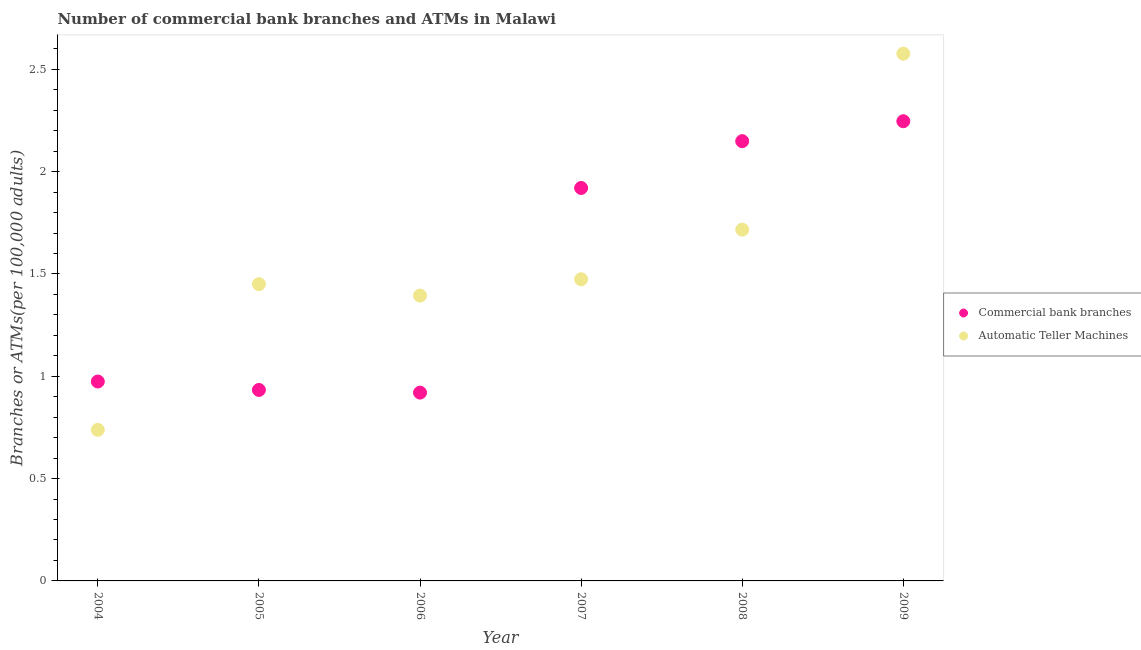Is the number of dotlines equal to the number of legend labels?
Your answer should be compact. Yes. What is the number of atms in 2009?
Provide a succinct answer. 2.58. Across all years, what is the maximum number of commercal bank branches?
Give a very brief answer. 2.25. Across all years, what is the minimum number of atms?
Your response must be concise. 0.74. What is the total number of commercal bank branches in the graph?
Ensure brevity in your answer.  9.14. What is the difference between the number of atms in 2004 and that in 2007?
Offer a very short reply. -0.74. What is the difference between the number of atms in 2007 and the number of commercal bank branches in 2008?
Your answer should be compact. -0.68. What is the average number of atms per year?
Your answer should be compact. 1.56. In the year 2009, what is the difference between the number of commercal bank branches and number of atms?
Ensure brevity in your answer.  -0.33. In how many years, is the number of commercal bank branches greater than 1.7?
Ensure brevity in your answer.  3. What is the ratio of the number of commercal bank branches in 2006 to that in 2009?
Offer a terse response. 0.41. What is the difference between the highest and the second highest number of atms?
Keep it short and to the point. 0.86. What is the difference between the highest and the lowest number of commercal bank branches?
Ensure brevity in your answer.  1.33. In how many years, is the number of atms greater than the average number of atms taken over all years?
Give a very brief answer. 2. How many years are there in the graph?
Keep it short and to the point. 6. Does the graph contain any zero values?
Provide a succinct answer. No. Does the graph contain grids?
Keep it short and to the point. No. Where does the legend appear in the graph?
Keep it short and to the point. Center right. How many legend labels are there?
Provide a succinct answer. 2. How are the legend labels stacked?
Offer a very short reply. Vertical. What is the title of the graph?
Give a very brief answer. Number of commercial bank branches and ATMs in Malawi. What is the label or title of the Y-axis?
Offer a terse response. Branches or ATMs(per 100,0 adults). What is the Branches or ATMs(per 100,000 adults) in Commercial bank branches in 2004?
Provide a short and direct response. 0.97. What is the Branches or ATMs(per 100,000 adults) in Automatic Teller Machines in 2004?
Your answer should be compact. 0.74. What is the Branches or ATMs(per 100,000 adults) in Commercial bank branches in 2005?
Provide a short and direct response. 0.93. What is the Branches or ATMs(per 100,000 adults) of Automatic Teller Machines in 2005?
Give a very brief answer. 1.45. What is the Branches or ATMs(per 100,000 adults) of Commercial bank branches in 2006?
Make the answer very short. 0.92. What is the Branches or ATMs(per 100,000 adults) of Automatic Teller Machines in 2006?
Make the answer very short. 1.39. What is the Branches or ATMs(per 100,000 adults) in Commercial bank branches in 2007?
Offer a terse response. 1.92. What is the Branches or ATMs(per 100,000 adults) in Automatic Teller Machines in 2007?
Provide a succinct answer. 1.47. What is the Branches or ATMs(per 100,000 adults) of Commercial bank branches in 2008?
Your answer should be very brief. 2.15. What is the Branches or ATMs(per 100,000 adults) of Automatic Teller Machines in 2008?
Your response must be concise. 1.72. What is the Branches or ATMs(per 100,000 adults) in Commercial bank branches in 2009?
Your response must be concise. 2.25. What is the Branches or ATMs(per 100,000 adults) in Automatic Teller Machines in 2009?
Ensure brevity in your answer.  2.58. Across all years, what is the maximum Branches or ATMs(per 100,000 adults) of Commercial bank branches?
Provide a succinct answer. 2.25. Across all years, what is the maximum Branches or ATMs(per 100,000 adults) in Automatic Teller Machines?
Give a very brief answer. 2.58. Across all years, what is the minimum Branches or ATMs(per 100,000 adults) in Commercial bank branches?
Offer a very short reply. 0.92. Across all years, what is the minimum Branches or ATMs(per 100,000 adults) in Automatic Teller Machines?
Make the answer very short. 0.74. What is the total Branches or ATMs(per 100,000 adults) in Commercial bank branches in the graph?
Your answer should be compact. 9.14. What is the total Branches or ATMs(per 100,000 adults) in Automatic Teller Machines in the graph?
Provide a short and direct response. 9.35. What is the difference between the Branches or ATMs(per 100,000 adults) of Commercial bank branches in 2004 and that in 2005?
Make the answer very short. 0.04. What is the difference between the Branches or ATMs(per 100,000 adults) in Automatic Teller Machines in 2004 and that in 2005?
Make the answer very short. -0.71. What is the difference between the Branches or ATMs(per 100,000 adults) in Commercial bank branches in 2004 and that in 2006?
Make the answer very short. 0.05. What is the difference between the Branches or ATMs(per 100,000 adults) of Automatic Teller Machines in 2004 and that in 2006?
Your response must be concise. -0.66. What is the difference between the Branches or ATMs(per 100,000 adults) in Commercial bank branches in 2004 and that in 2007?
Your response must be concise. -0.95. What is the difference between the Branches or ATMs(per 100,000 adults) of Automatic Teller Machines in 2004 and that in 2007?
Give a very brief answer. -0.74. What is the difference between the Branches or ATMs(per 100,000 adults) of Commercial bank branches in 2004 and that in 2008?
Offer a terse response. -1.17. What is the difference between the Branches or ATMs(per 100,000 adults) in Automatic Teller Machines in 2004 and that in 2008?
Give a very brief answer. -0.98. What is the difference between the Branches or ATMs(per 100,000 adults) of Commercial bank branches in 2004 and that in 2009?
Make the answer very short. -1.27. What is the difference between the Branches or ATMs(per 100,000 adults) of Automatic Teller Machines in 2004 and that in 2009?
Your answer should be compact. -1.84. What is the difference between the Branches or ATMs(per 100,000 adults) of Commercial bank branches in 2005 and that in 2006?
Offer a terse response. 0.01. What is the difference between the Branches or ATMs(per 100,000 adults) of Automatic Teller Machines in 2005 and that in 2006?
Ensure brevity in your answer.  0.06. What is the difference between the Branches or ATMs(per 100,000 adults) of Commercial bank branches in 2005 and that in 2007?
Your response must be concise. -0.99. What is the difference between the Branches or ATMs(per 100,000 adults) of Automatic Teller Machines in 2005 and that in 2007?
Ensure brevity in your answer.  -0.02. What is the difference between the Branches or ATMs(per 100,000 adults) of Commercial bank branches in 2005 and that in 2008?
Your response must be concise. -1.22. What is the difference between the Branches or ATMs(per 100,000 adults) of Automatic Teller Machines in 2005 and that in 2008?
Your answer should be very brief. -0.27. What is the difference between the Branches or ATMs(per 100,000 adults) in Commercial bank branches in 2005 and that in 2009?
Provide a succinct answer. -1.31. What is the difference between the Branches or ATMs(per 100,000 adults) of Automatic Teller Machines in 2005 and that in 2009?
Offer a very short reply. -1.13. What is the difference between the Branches or ATMs(per 100,000 adults) of Commercial bank branches in 2006 and that in 2007?
Offer a terse response. -1. What is the difference between the Branches or ATMs(per 100,000 adults) of Automatic Teller Machines in 2006 and that in 2007?
Give a very brief answer. -0.08. What is the difference between the Branches or ATMs(per 100,000 adults) of Commercial bank branches in 2006 and that in 2008?
Your answer should be compact. -1.23. What is the difference between the Branches or ATMs(per 100,000 adults) of Automatic Teller Machines in 2006 and that in 2008?
Your answer should be very brief. -0.32. What is the difference between the Branches or ATMs(per 100,000 adults) of Commercial bank branches in 2006 and that in 2009?
Give a very brief answer. -1.33. What is the difference between the Branches or ATMs(per 100,000 adults) of Automatic Teller Machines in 2006 and that in 2009?
Your answer should be very brief. -1.18. What is the difference between the Branches or ATMs(per 100,000 adults) in Commercial bank branches in 2007 and that in 2008?
Offer a very short reply. -0.23. What is the difference between the Branches or ATMs(per 100,000 adults) in Automatic Teller Machines in 2007 and that in 2008?
Provide a short and direct response. -0.24. What is the difference between the Branches or ATMs(per 100,000 adults) in Commercial bank branches in 2007 and that in 2009?
Make the answer very short. -0.33. What is the difference between the Branches or ATMs(per 100,000 adults) in Automatic Teller Machines in 2007 and that in 2009?
Keep it short and to the point. -1.1. What is the difference between the Branches or ATMs(per 100,000 adults) in Commercial bank branches in 2008 and that in 2009?
Offer a very short reply. -0.1. What is the difference between the Branches or ATMs(per 100,000 adults) of Automatic Teller Machines in 2008 and that in 2009?
Provide a succinct answer. -0.86. What is the difference between the Branches or ATMs(per 100,000 adults) of Commercial bank branches in 2004 and the Branches or ATMs(per 100,000 adults) of Automatic Teller Machines in 2005?
Offer a terse response. -0.48. What is the difference between the Branches or ATMs(per 100,000 adults) in Commercial bank branches in 2004 and the Branches or ATMs(per 100,000 adults) in Automatic Teller Machines in 2006?
Offer a terse response. -0.42. What is the difference between the Branches or ATMs(per 100,000 adults) in Commercial bank branches in 2004 and the Branches or ATMs(per 100,000 adults) in Automatic Teller Machines in 2007?
Keep it short and to the point. -0.5. What is the difference between the Branches or ATMs(per 100,000 adults) of Commercial bank branches in 2004 and the Branches or ATMs(per 100,000 adults) of Automatic Teller Machines in 2008?
Your answer should be compact. -0.74. What is the difference between the Branches or ATMs(per 100,000 adults) in Commercial bank branches in 2004 and the Branches or ATMs(per 100,000 adults) in Automatic Teller Machines in 2009?
Your response must be concise. -1.6. What is the difference between the Branches or ATMs(per 100,000 adults) in Commercial bank branches in 2005 and the Branches or ATMs(per 100,000 adults) in Automatic Teller Machines in 2006?
Give a very brief answer. -0.46. What is the difference between the Branches or ATMs(per 100,000 adults) of Commercial bank branches in 2005 and the Branches or ATMs(per 100,000 adults) of Automatic Teller Machines in 2007?
Your answer should be very brief. -0.54. What is the difference between the Branches or ATMs(per 100,000 adults) in Commercial bank branches in 2005 and the Branches or ATMs(per 100,000 adults) in Automatic Teller Machines in 2008?
Offer a very short reply. -0.78. What is the difference between the Branches or ATMs(per 100,000 adults) of Commercial bank branches in 2005 and the Branches or ATMs(per 100,000 adults) of Automatic Teller Machines in 2009?
Your answer should be very brief. -1.64. What is the difference between the Branches or ATMs(per 100,000 adults) in Commercial bank branches in 2006 and the Branches or ATMs(per 100,000 adults) in Automatic Teller Machines in 2007?
Offer a terse response. -0.55. What is the difference between the Branches or ATMs(per 100,000 adults) in Commercial bank branches in 2006 and the Branches or ATMs(per 100,000 adults) in Automatic Teller Machines in 2008?
Your answer should be very brief. -0.8. What is the difference between the Branches or ATMs(per 100,000 adults) in Commercial bank branches in 2006 and the Branches or ATMs(per 100,000 adults) in Automatic Teller Machines in 2009?
Offer a very short reply. -1.66. What is the difference between the Branches or ATMs(per 100,000 adults) of Commercial bank branches in 2007 and the Branches or ATMs(per 100,000 adults) of Automatic Teller Machines in 2008?
Keep it short and to the point. 0.2. What is the difference between the Branches or ATMs(per 100,000 adults) of Commercial bank branches in 2007 and the Branches or ATMs(per 100,000 adults) of Automatic Teller Machines in 2009?
Offer a terse response. -0.66. What is the difference between the Branches or ATMs(per 100,000 adults) of Commercial bank branches in 2008 and the Branches or ATMs(per 100,000 adults) of Automatic Teller Machines in 2009?
Your answer should be compact. -0.43. What is the average Branches or ATMs(per 100,000 adults) in Commercial bank branches per year?
Offer a very short reply. 1.52. What is the average Branches or ATMs(per 100,000 adults) in Automatic Teller Machines per year?
Keep it short and to the point. 1.56. In the year 2004, what is the difference between the Branches or ATMs(per 100,000 adults) in Commercial bank branches and Branches or ATMs(per 100,000 adults) in Automatic Teller Machines?
Your answer should be compact. 0.24. In the year 2005, what is the difference between the Branches or ATMs(per 100,000 adults) in Commercial bank branches and Branches or ATMs(per 100,000 adults) in Automatic Teller Machines?
Offer a terse response. -0.52. In the year 2006, what is the difference between the Branches or ATMs(per 100,000 adults) in Commercial bank branches and Branches or ATMs(per 100,000 adults) in Automatic Teller Machines?
Your answer should be compact. -0.47. In the year 2007, what is the difference between the Branches or ATMs(per 100,000 adults) in Commercial bank branches and Branches or ATMs(per 100,000 adults) in Automatic Teller Machines?
Ensure brevity in your answer.  0.45. In the year 2008, what is the difference between the Branches or ATMs(per 100,000 adults) of Commercial bank branches and Branches or ATMs(per 100,000 adults) of Automatic Teller Machines?
Make the answer very short. 0.43. In the year 2009, what is the difference between the Branches or ATMs(per 100,000 adults) in Commercial bank branches and Branches or ATMs(per 100,000 adults) in Automatic Teller Machines?
Offer a terse response. -0.33. What is the ratio of the Branches or ATMs(per 100,000 adults) of Commercial bank branches in 2004 to that in 2005?
Offer a terse response. 1.04. What is the ratio of the Branches or ATMs(per 100,000 adults) in Automatic Teller Machines in 2004 to that in 2005?
Provide a succinct answer. 0.51. What is the ratio of the Branches or ATMs(per 100,000 adults) of Commercial bank branches in 2004 to that in 2006?
Your response must be concise. 1.06. What is the ratio of the Branches or ATMs(per 100,000 adults) of Automatic Teller Machines in 2004 to that in 2006?
Provide a short and direct response. 0.53. What is the ratio of the Branches or ATMs(per 100,000 adults) in Commercial bank branches in 2004 to that in 2007?
Your answer should be compact. 0.51. What is the ratio of the Branches or ATMs(per 100,000 adults) in Automatic Teller Machines in 2004 to that in 2007?
Offer a very short reply. 0.5. What is the ratio of the Branches or ATMs(per 100,000 adults) in Commercial bank branches in 2004 to that in 2008?
Give a very brief answer. 0.45. What is the ratio of the Branches or ATMs(per 100,000 adults) of Automatic Teller Machines in 2004 to that in 2008?
Your response must be concise. 0.43. What is the ratio of the Branches or ATMs(per 100,000 adults) in Commercial bank branches in 2004 to that in 2009?
Your answer should be compact. 0.43. What is the ratio of the Branches or ATMs(per 100,000 adults) in Automatic Teller Machines in 2004 to that in 2009?
Give a very brief answer. 0.29. What is the ratio of the Branches or ATMs(per 100,000 adults) in Commercial bank branches in 2005 to that in 2006?
Offer a very short reply. 1.01. What is the ratio of the Branches or ATMs(per 100,000 adults) of Automatic Teller Machines in 2005 to that in 2006?
Your response must be concise. 1.04. What is the ratio of the Branches or ATMs(per 100,000 adults) in Commercial bank branches in 2005 to that in 2007?
Ensure brevity in your answer.  0.49. What is the ratio of the Branches or ATMs(per 100,000 adults) of Automatic Teller Machines in 2005 to that in 2007?
Provide a succinct answer. 0.98. What is the ratio of the Branches or ATMs(per 100,000 adults) of Commercial bank branches in 2005 to that in 2008?
Provide a short and direct response. 0.43. What is the ratio of the Branches or ATMs(per 100,000 adults) of Automatic Teller Machines in 2005 to that in 2008?
Make the answer very short. 0.84. What is the ratio of the Branches or ATMs(per 100,000 adults) in Commercial bank branches in 2005 to that in 2009?
Your answer should be compact. 0.42. What is the ratio of the Branches or ATMs(per 100,000 adults) of Automatic Teller Machines in 2005 to that in 2009?
Provide a short and direct response. 0.56. What is the ratio of the Branches or ATMs(per 100,000 adults) in Commercial bank branches in 2006 to that in 2007?
Offer a very short reply. 0.48. What is the ratio of the Branches or ATMs(per 100,000 adults) of Automatic Teller Machines in 2006 to that in 2007?
Keep it short and to the point. 0.95. What is the ratio of the Branches or ATMs(per 100,000 adults) of Commercial bank branches in 2006 to that in 2008?
Your response must be concise. 0.43. What is the ratio of the Branches or ATMs(per 100,000 adults) in Automatic Teller Machines in 2006 to that in 2008?
Your answer should be very brief. 0.81. What is the ratio of the Branches or ATMs(per 100,000 adults) in Commercial bank branches in 2006 to that in 2009?
Make the answer very short. 0.41. What is the ratio of the Branches or ATMs(per 100,000 adults) in Automatic Teller Machines in 2006 to that in 2009?
Your answer should be compact. 0.54. What is the ratio of the Branches or ATMs(per 100,000 adults) in Commercial bank branches in 2007 to that in 2008?
Keep it short and to the point. 0.89. What is the ratio of the Branches or ATMs(per 100,000 adults) of Automatic Teller Machines in 2007 to that in 2008?
Make the answer very short. 0.86. What is the ratio of the Branches or ATMs(per 100,000 adults) in Commercial bank branches in 2007 to that in 2009?
Your answer should be compact. 0.85. What is the ratio of the Branches or ATMs(per 100,000 adults) of Automatic Teller Machines in 2007 to that in 2009?
Keep it short and to the point. 0.57. What is the ratio of the Branches or ATMs(per 100,000 adults) in Commercial bank branches in 2008 to that in 2009?
Provide a succinct answer. 0.96. What is the ratio of the Branches or ATMs(per 100,000 adults) of Automatic Teller Machines in 2008 to that in 2009?
Give a very brief answer. 0.67. What is the difference between the highest and the second highest Branches or ATMs(per 100,000 adults) in Commercial bank branches?
Your answer should be very brief. 0.1. What is the difference between the highest and the second highest Branches or ATMs(per 100,000 adults) in Automatic Teller Machines?
Give a very brief answer. 0.86. What is the difference between the highest and the lowest Branches or ATMs(per 100,000 adults) of Commercial bank branches?
Offer a terse response. 1.33. What is the difference between the highest and the lowest Branches or ATMs(per 100,000 adults) in Automatic Teller Machines?
Offer a very short reply. 1.84. 